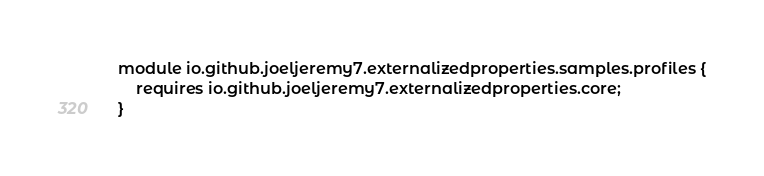Convert code to text. <code><loc_0><loc_0><loc_500><loc_500><_Java_>module io.github.joeljeremy7.externalizedproperties.samples.profiles {
    requires io.github.joeljeremy7.externalizedproperties.core;
}</code> 